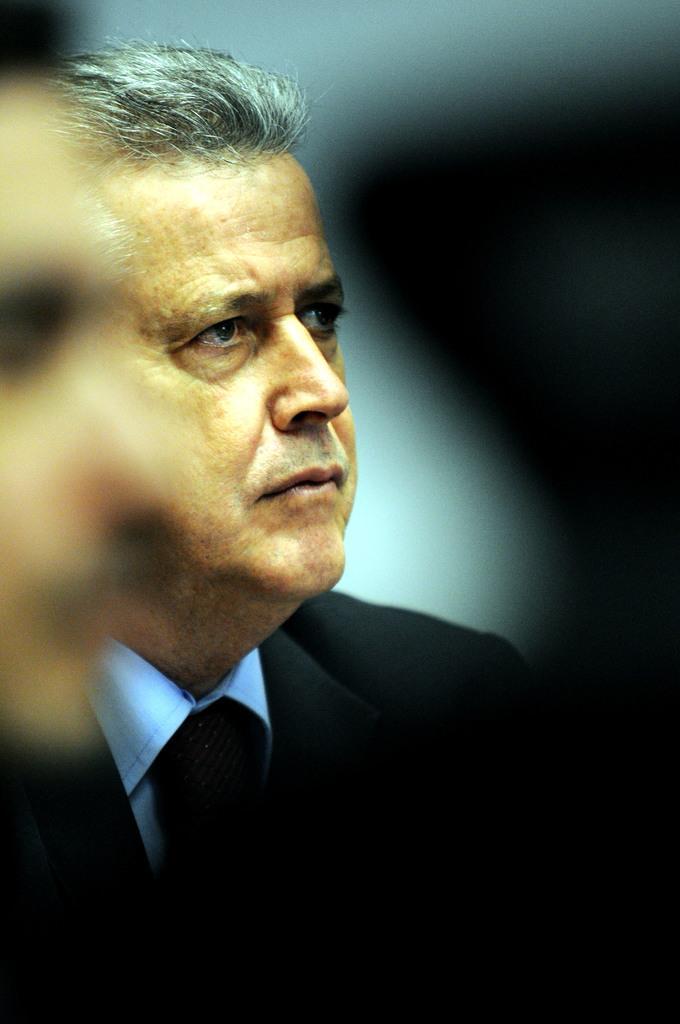How would you summarize this image in a sentence or two? In this picture there is a man on the right side of the image. 